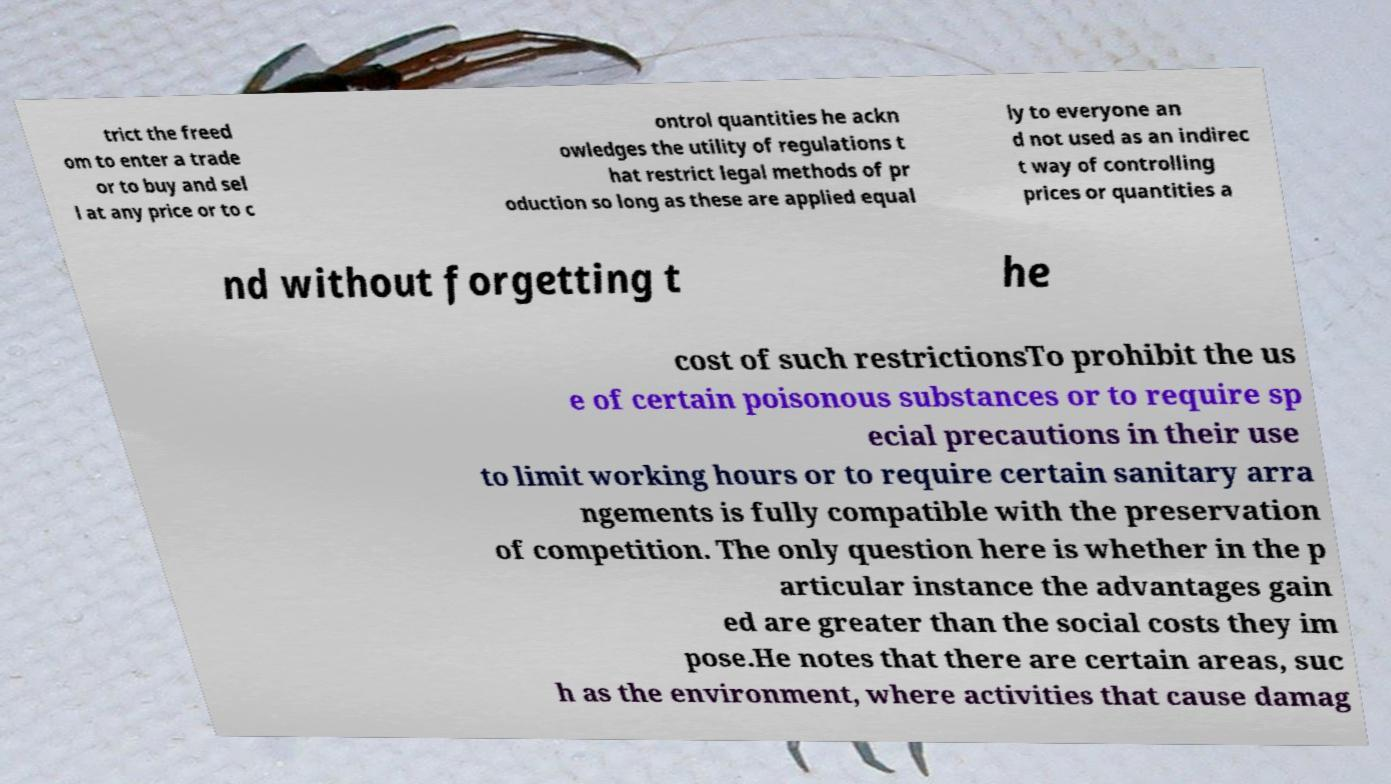What messages or text are displayed in this image? I need them in a readable, typed format. trict the freed om to enter a trade or to buy and sel l at any price or to c ontrol quantities he ackn owledges the utility of regulations t hat restrict legal methods of pr oduction so long as these are applied equal ly to everyone an d not used as an indirec t way of controlling prices or quantities a nd without forgetting t he cost of such restrictionsTo prohibit the us e of certain poisonous substances or to require sp ecial precautions in their use to limit working hours or to require certain sanitary arra ngements is fully compatible with the preservation of competition. The only question here is whether in the p articular instance the advantages gain ed are greater than the social costs they im pose.He notes that there are certain areas, suc h as the environment, where activities that cause damag 